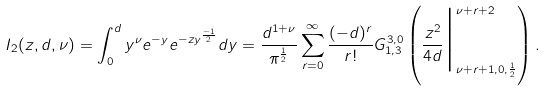Convert formula to latex. <formula><loc_0><loc_0><loc_500><loc_500>I _ { 2 } ( z , d , \nu ) = \int _ { 0 } ^ { d } y ^ { \nu } e ^ { - y } e ^ { - z y ^ { \frac { - 1 } { 2 } } } d y = \frac { d ^ { 1 + \nu } } { \pi ^ { \frac { 1 } { 2 } } } \sum _ { r = 0 } ^ { \infty } \frac { ( - d ) ^ { r } } { r ! } G ^ { 3 , 0 } _ { 1 , 3 } \left ( \frac { z ^ { 2 } } { 4 d } \Big | _ { \nu + r + 1 , 0 , \frac { 1 } { 2 } } ^ { \nu + r + 2 } \right ) .</formula> 